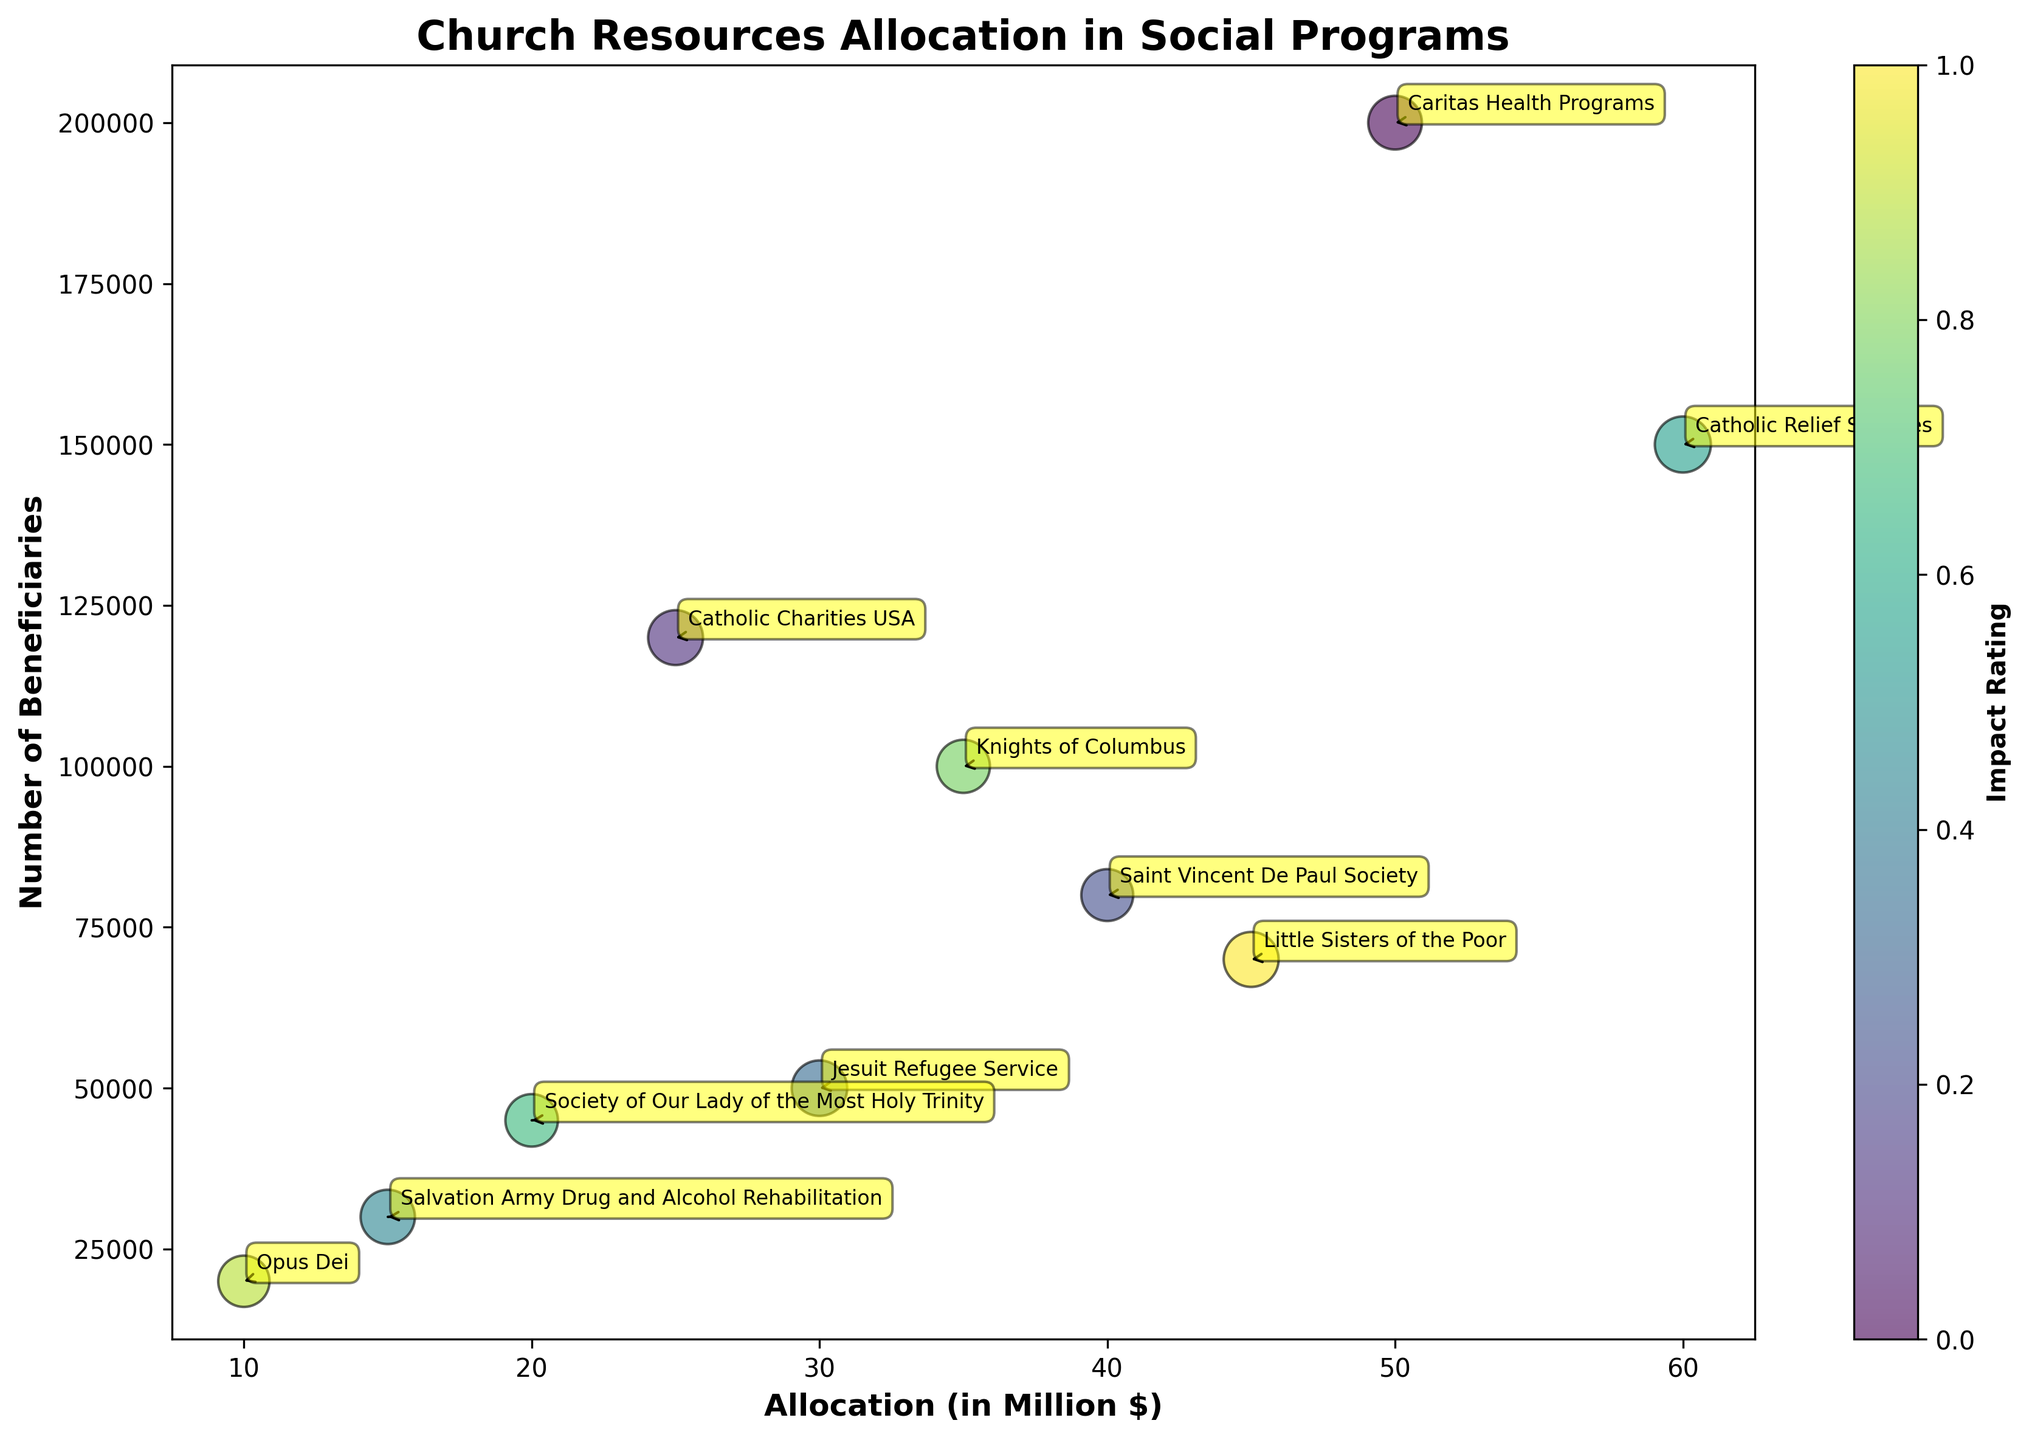What is the title of the bubble chart? The title is usually located at the top of the chart. It provides an overall description of the data presented. By looking at the top of the figure, we can see the title clearly stated.
Answer: Church Resources Allocation in Social Programs How many social programs are represented in the chart? Each bubble in the chart represents a different social program. By counting the number of distinct bubbles, we can determine the total number of programs shown.
Answer: 10 Which program has the highest allocation in millions of dollars? We can identify the program with the highest allocation by looking for the bubble located furthest to the right along the horizontal axis. Following it, we can see which program label it has.
Answer: Catholic Relief Services How does the impact rating correlate with the size of the bubbles? The size of the bubbles represents the impact rating. By comparing different bubbles, one can see that larger bubbles correspond to higher impact ratings.
Answer: Larger bubbles have higher impact ratings Which program supports the highest number of beneficiaries? To find this, look for the bubble placed highest along the vertical axis. This indicates the highest number of beneficiaries.
Answer: Caritas Health Programs What is the total allocation for Healthcare and Housing combined? Add the allocation amounts for Caritas Health Programs (Healthcare) and Saint Vincent De Paul Society (Housing). 50 million (Healthcare) + 40 million (Housing) = 90 million
Answer: 90 million Which program has both a high number of beneficiaries and a high impact rating? We need to look for a bubble that is both high on the vertical axis (indicating many beneficiaries) and relatively large in size (indicating higher impact rating).
Answer: Caritas Health Programs Compare the impact rating and number of beneficiaries between Catholic Charities USA and Jesuit Refugee Service. From the figure, note the size and vertical position of bubbles for Catholic Charities USA and Jesuit Refugee Service. Catholic Charities USA has a higher beneficiary count but a slightly lower impact rating compared to Jesuit Refugee Service.
Answer: Catholic Charities USA has more beneficiaries; Jesuit Refugee Service has a higher impact rating What is the range of allocations across all programs? Identify the minimum and maximum values along the horizontal axis. The lowest allocation is 10 million, and the highest is 60 million. Hence, the range is 60 - 10 = 50 million.
Answer: 50 million Which programs have an impact rating of 4.7 or higher? Look for bubbles of certain sizes, specifically those that are larger (since they represent higher impact ratings). Check the labels of these bubbles to identify the programs.
Answer: Caritas Health Programs, Catholic Charities USA, Jesuit Refugee Service, Catholic Relief Services, Little Sisters of the Poor 